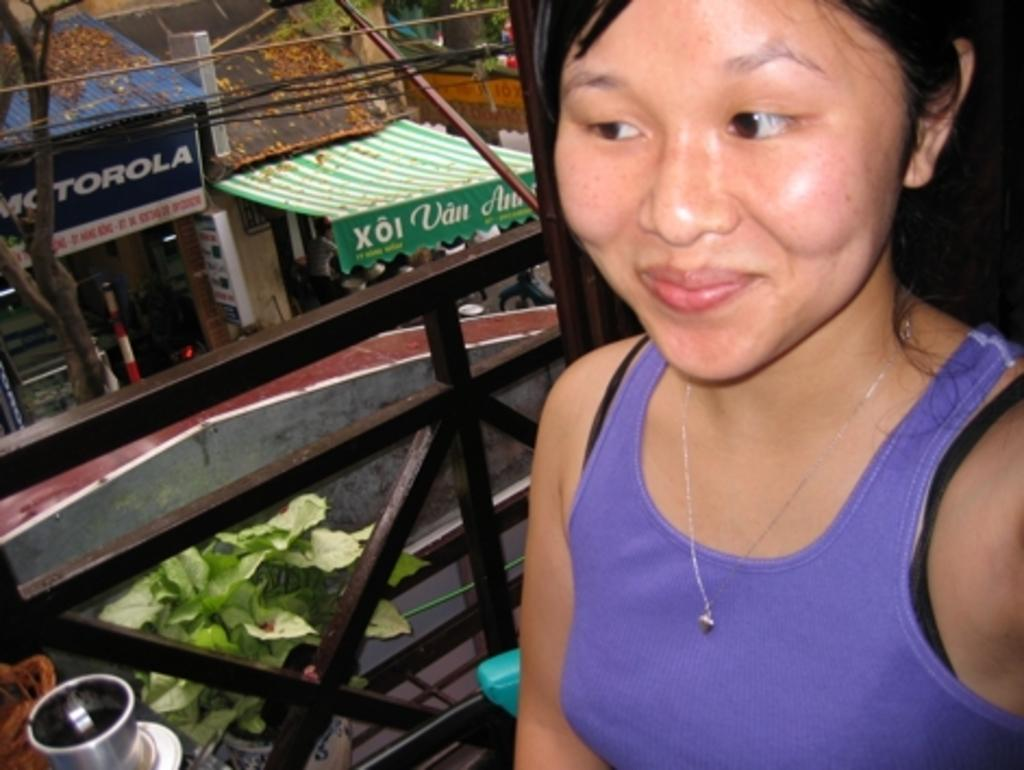Who is present in the image? There is a woman in the image. What is the woman doing in the image? The woman is looking and smiling at someone. What can be seen in the background of the image? There are many shops and trees in the background of the image. What type of noise can be heard coming from the war in the image? There is no war present in the image, so it's not possible to determine what, if any, noise might be heard. 